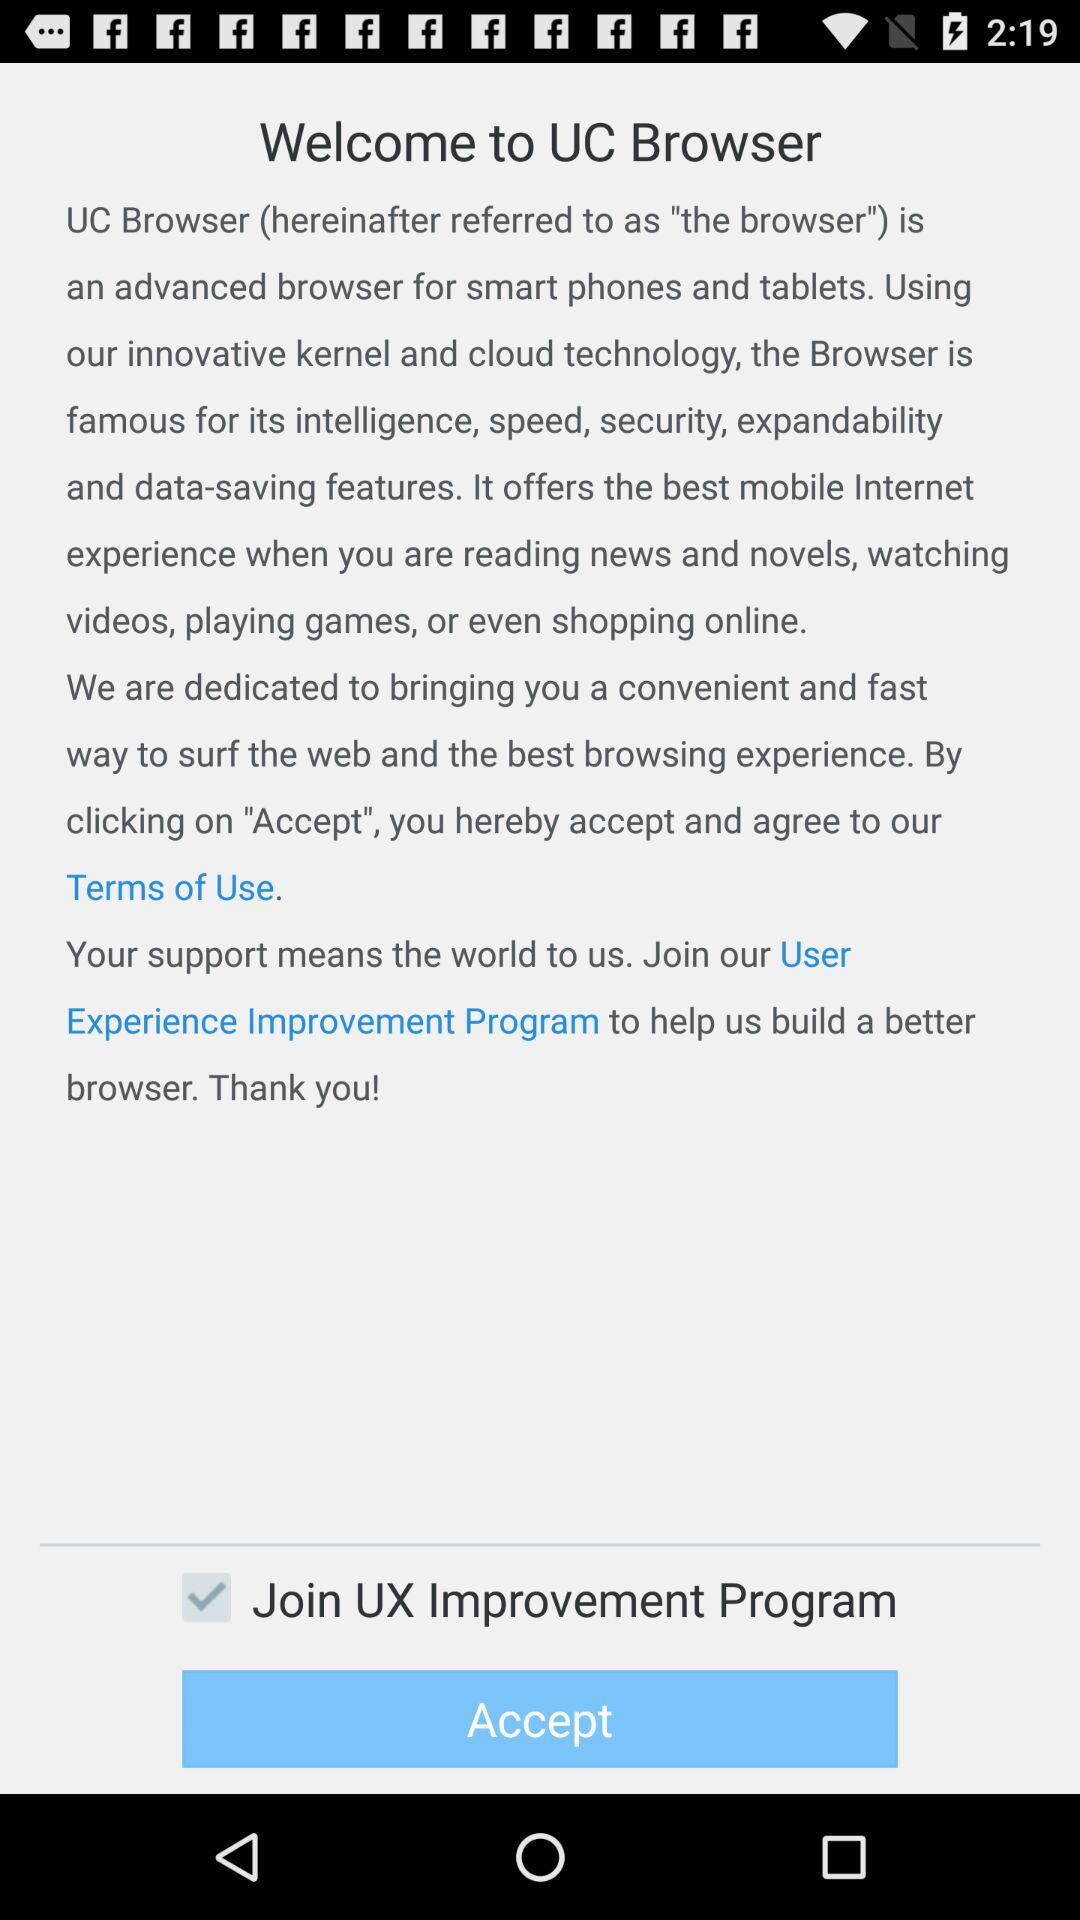Why is the "UC Browser" famous for? The "UC Browser" is famous for its intelligence, speed, security, expandability and data-saving features. 